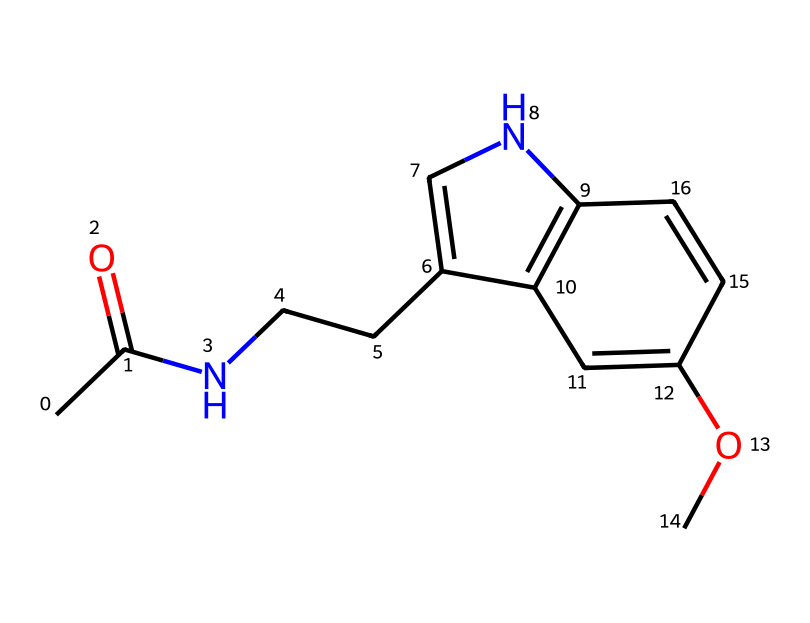what is the molecular formula of this compound? To determine the molecular formula, we can count the distinct atoms present in the structure based on the SMILES representation. Specifically, we count 12 carbon atoms (C), 13 hydrogen atoms (H), 1 nitrogen atom (N), and 3 oxygen atoms (O). Therefore, the molecular formula is assembled as C12H13N1O3.
Answer: C12H13N1O3 how many rings are present in the structure? By examining the SMILES representation, we can identify ring structures using the notation of numbers indicating ring closures. Two rings can be found in the structure due to the presence of two pairs of matching numbers (1 and 2) in the SMILES.
Answer: 2 what functional groups are present in melatonin? In the structural representation, we can identify key functional groups such as an acetamide group (CC(=O)N) and a methoxy group (OC). The presence of these groups indicates the molecular features of melatonin.
Answer: acetamide and methoxy how many double bonds are in this molecule? In the SMILES notation, double bonds are indicated by the "=" sign. Counting the "=" symbols present in the structure shows that there are 3 double bonds within the compound's structure, which contribute to its aromatic features.
Answer: 3 what is the primary medicinal use of this compound? The compound depicted is melatonin, which is primarily used as a sleep aid to help regulate sleep cycles, particularly for people with irregular schedules or sleep disorders. This is a widely recognized pharmacological application of melatonin.
Answer: sleep aid what type of receptor does melatonin primarily target? Melatonin primarily binds to and activates melatonin receptors, specifically the MT1 and MT2 receptors in the central nervous system. Understanding these receptors assists in understanding its sleep-regulating effects.
Answer: melatonin receptors 